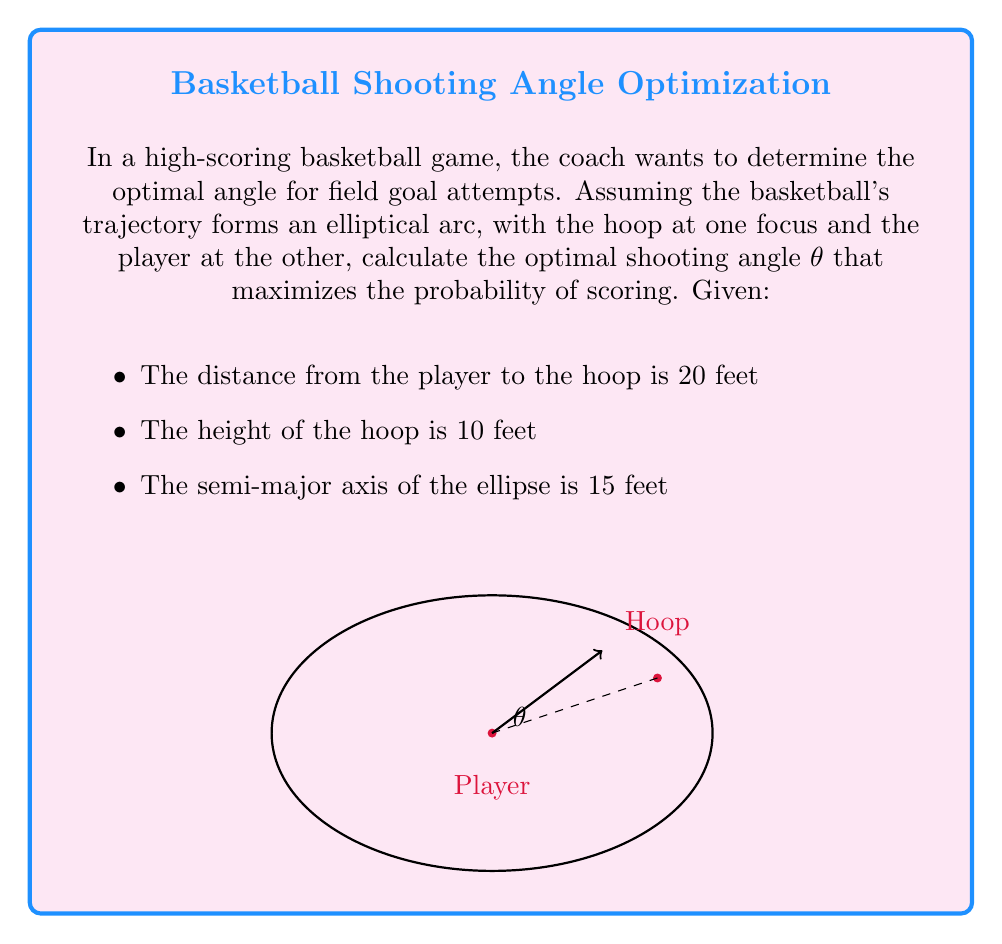Show me your answer to this math problem. To solve this problem, we'll use the properties of ellipses and some trigonometry:

1) In an ellipse, the sum of the distances from any point on the ellipse to the two foci is constant and equal to the major axis length.

2) The eccentricity of an ellipse is given by $e = \frac{c}{a}$, where $c$ is the distance from the center to a focus, and $a$ is the semi-major axis.

3) The distance between foci is $2c$.

Let's solve step by step:

1) Distance between foci (player to hoop) = 20 feet
   $2c = 20$, so $c = 10$

2) Semi-major axis $a = 15$ feet

3) Calculate eccentricity:
   $e = \frac{c}{a} = \frac{10}{15} = \frac{2}{3}$

4) The optimal angle is given by:
   $\cos \theta = e = \frac{2}{3}$

5) Therefore:
   $\theta = \arccos(\frac{2}{3})$

6) Convert to degrees:
   $\theta \approx 48.19°$

This angle maximizes the probability of scoring by providing the optimal balance between the initial velocity needed and the margin for error in the shot.
Answer: $\theta \approx 48.19°$ 